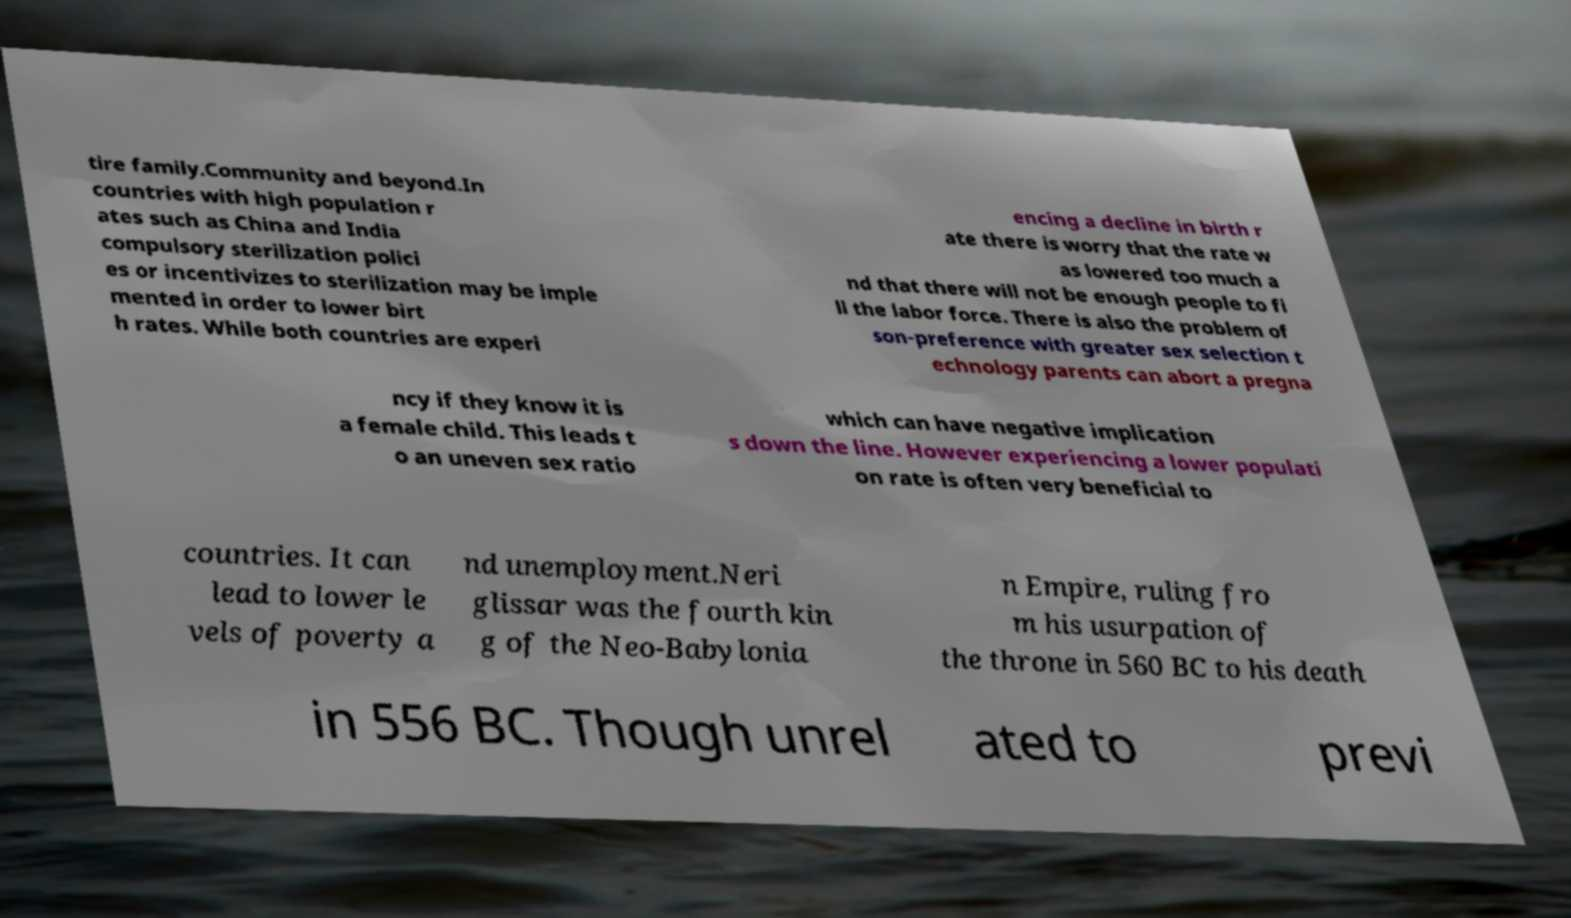What messages or text are displayed in this image? I need them in a readable, typed format. tire family.Community and beyond.In countries with high population r ates such as China and India compulsory sterilization polici es or incentivizes to sterilization may be imple mented in order to lower birt h rates. While both countries are experi encing a decline in birth r ate there is worry that the rate w as lowered too much a nd that there will not be enough people to fi ll the labor force. There is also the problem of son-preference with greater sex selection t echnology parents can abort a pregna ncy if they know it is a female child. This leads t o an uneven sex ratio which can have negative implication s down the line. However experiencing a lower populati on rate is often very beneficial to countries. It can lead to lower le vels of poverty a nd unemployment.Neri glissar was the fourth kin g of the Neo-Babylonia n Empire, ruling fro m his usurpation of the throne in 560 BC to his death in 556 BC. Though unrel ated to previ 